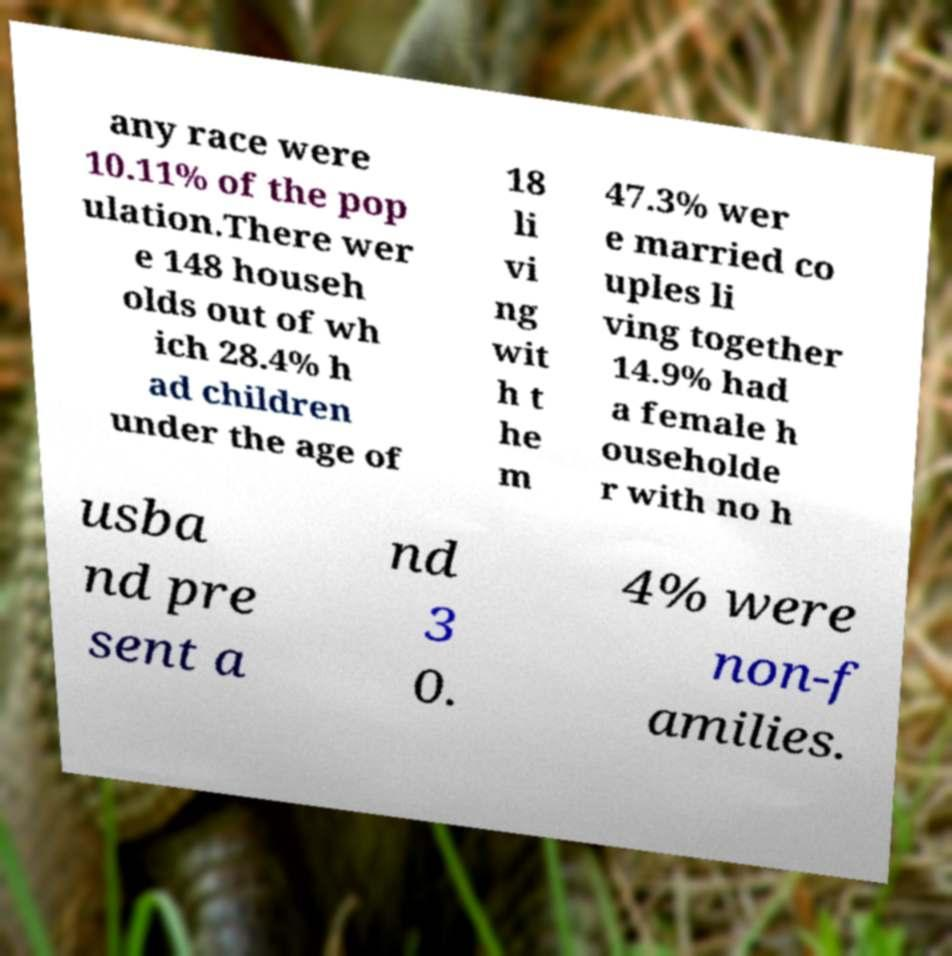Please read and relay the text visible in this image. What does it say? any race were 10.11% of the pop ulation.There wer e 148 househ olds out of wh ich 28.4% h ad children under the age of 18 li vi ng wit h t he m 47.3% wer e married co uples li ving together 14.9% had a female h ouseholde r with no h usba nd pre sent a nd 3 0. 4% were non-f amilies. 